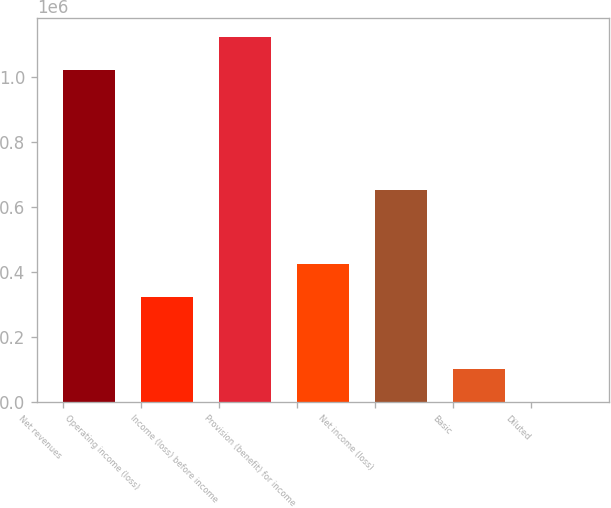Convert chart to OTSL. <chart><loc_0><loc_0><loc_500><loc_500><bar_chart><fcel>Net revenues<fcel>Operating income (loss)<fcel>Income (loss) before income<fcel>Provision (benefit) for income<fcel>Net income (loss)<fcel>Basic<fcel>Diluted<nl><fcel>1.02099e+06<fcel>322192<fcel>1.12342e+06<fcel>424619<fcel>652450<fcel>102429<fcel>1.9<nl></chart> 